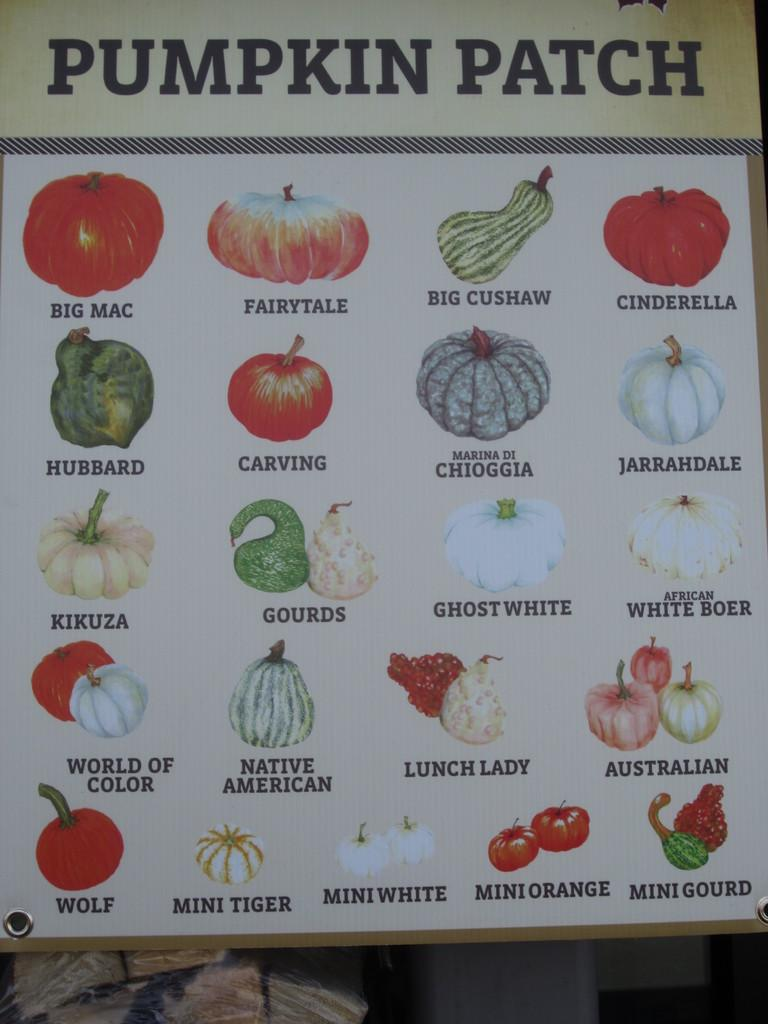What is depicted on the poster in the image? There is a poster with pictures of fruits and vegetables in the image. What can be seen at the bottom of the image? There are objects at the bottom of the image. How does the pipe connect to the shop in the image? There is no pipe or shop present in the image. 